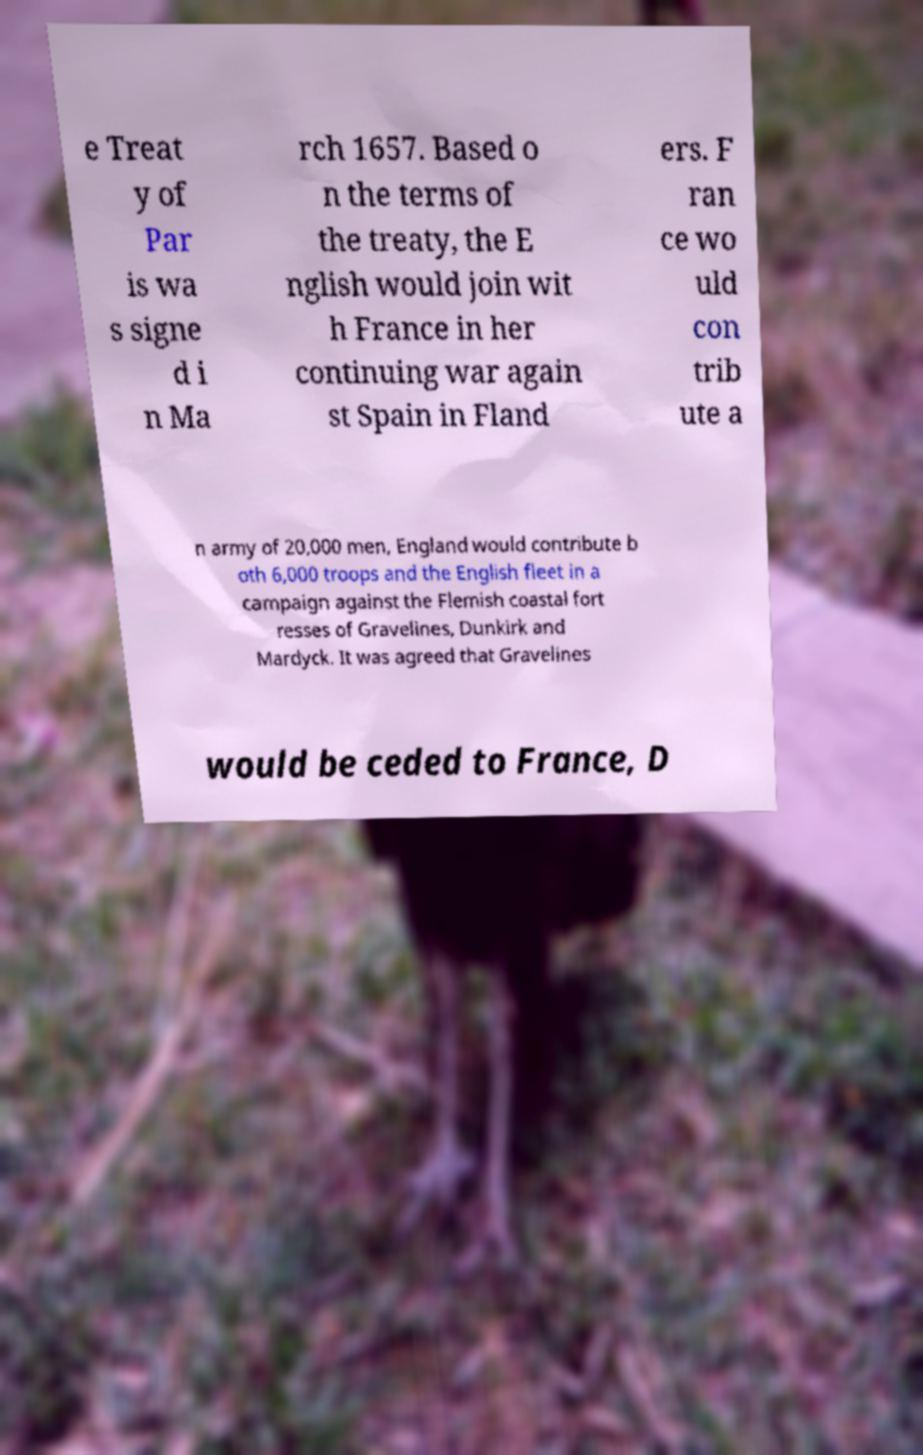What messages or text are displayed in this image? I need them in a readable, typed format. e Treat y of Par is wa s signe d i n Ma rch 1657. Based o n the terms of the treaty, the E nglish would join wit h France in her continuing war again st Spain in Fland ers. F ran ce wo uld con trib ute a n army of 20,000 men, England would contribute b oth 6,000 troops and the English fleet in a campaign against the Flemish coastal fort resses of Gravelines, Dunkirk and Mardyck. It was agreed that Gravelines would be ceded to France, D 